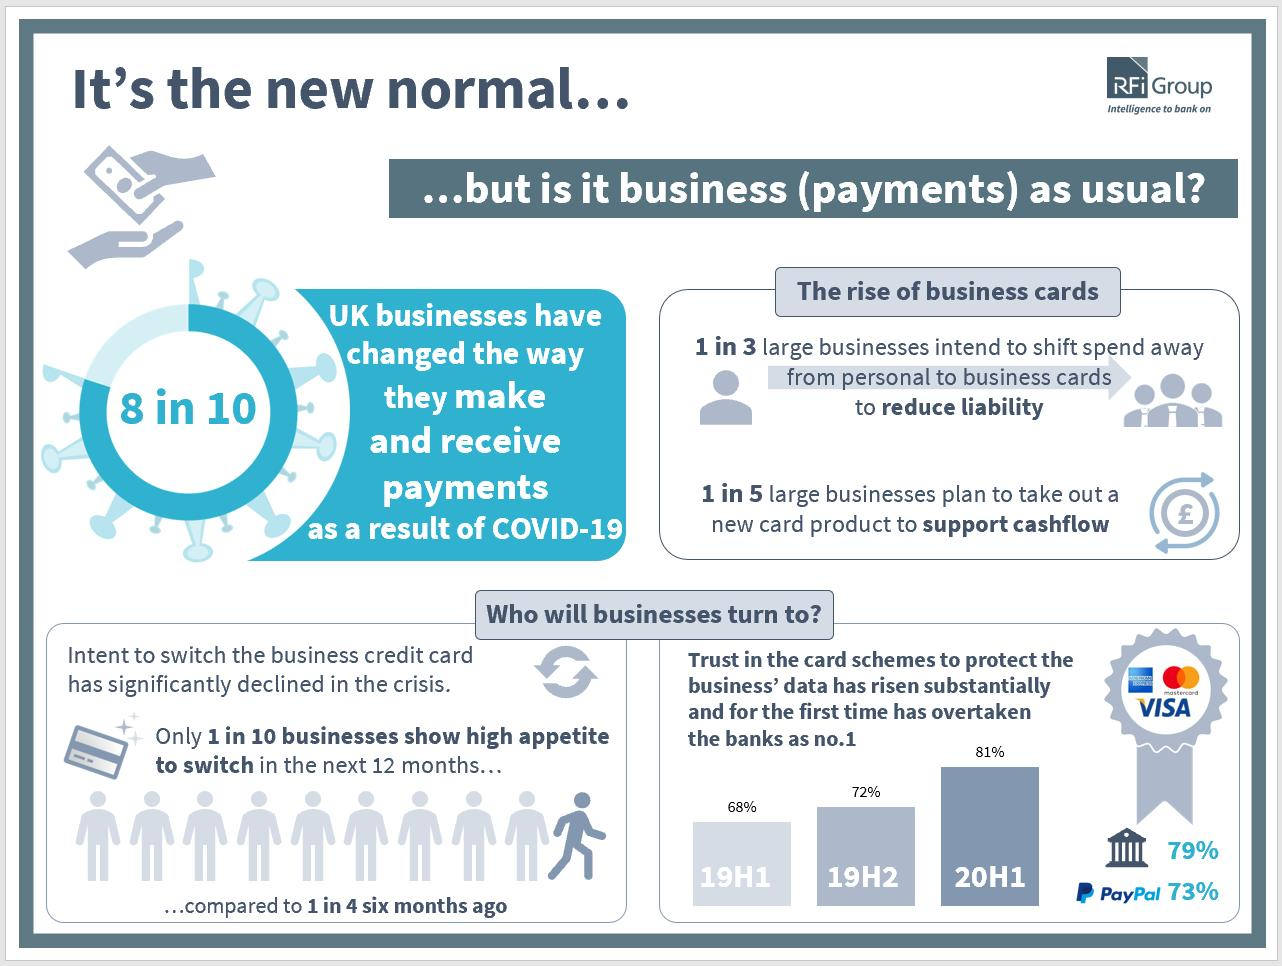Mention a couple of crucial points in this snapshot. According to a recent survey, approximately 10% of businesses are currently considering switching their credit card within the next 12 months. The three credit cards shown in the image are American Express, MasterCard, and Visa. A large majority of UK businesses, approximately 80%, have changed the way they make and receive payments. 